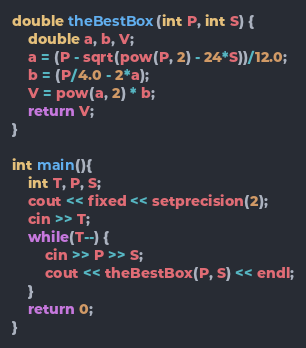<code> <loc_0><loc_0><loc_500><loc_500><_C++_>double theBestBox(int P, int S) {
	double a, b, V;
	a = (P - sqrt(pow(P, 2) - 24*S))/12.0;
	b = (P/4.0 - 2*a);
	V = pow(a, 2) * b;
	return V;
}

int main(){
	int T, P, S;
	cout << fixed << setprecision(2);
	cin >> T;
	while(T--) {
		cin >> P >> S;
		cout << theBestBox(P, S) << endl;
	}
	return 0;
}</code> 